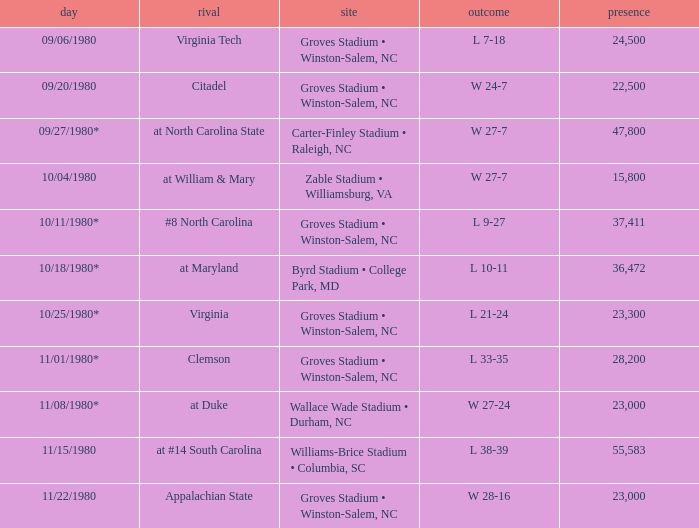How many people attended when Wake Forest played Virginia Tech? 24500.0. 